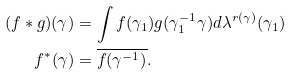<formula> <loc_0><loc_0><loc_500><loc_500>( f * g ) ( \gamma ) & = \int f ( \gamma _ { 1 } ) g ( \gamma _ { 1 } ^ { - 1 } \gamma ) d \lambda ^ { r ( \gamma ) } ( \gamma _ { 1 } ) \\ f ^ { * } ( \gamma ) & = \overline { f ( \gamma ^ { - 1 } ) } .</formula> 